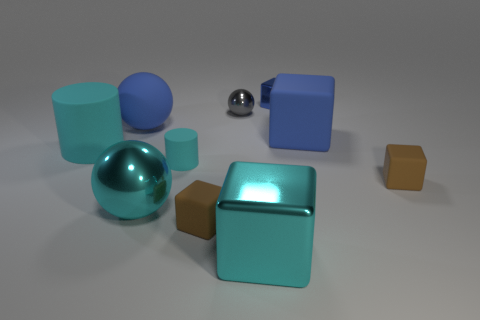Subtract all large cyan blocks. How many blocks are left? 4 Subtract all red balls. How many blue blocks are left? 2 Subtract all brown blocks. How many blocks are left? 3 Subtract 2 cubes. How many cubes are left? 3 Subtract all cyan blocks. Subtract all brown balls. How many blocks are left? 4 Subtract all balls. How many objects are left? 7 Add 3 blue cubes. How many blue cubes are left? 5 Add 6 blue things. How many blue things exist? 9 Subtract 0 purple cylinders. How many objects are left? 10 Subtract all cubes. Subtract all gray rubber things. How many objects are left? 5 